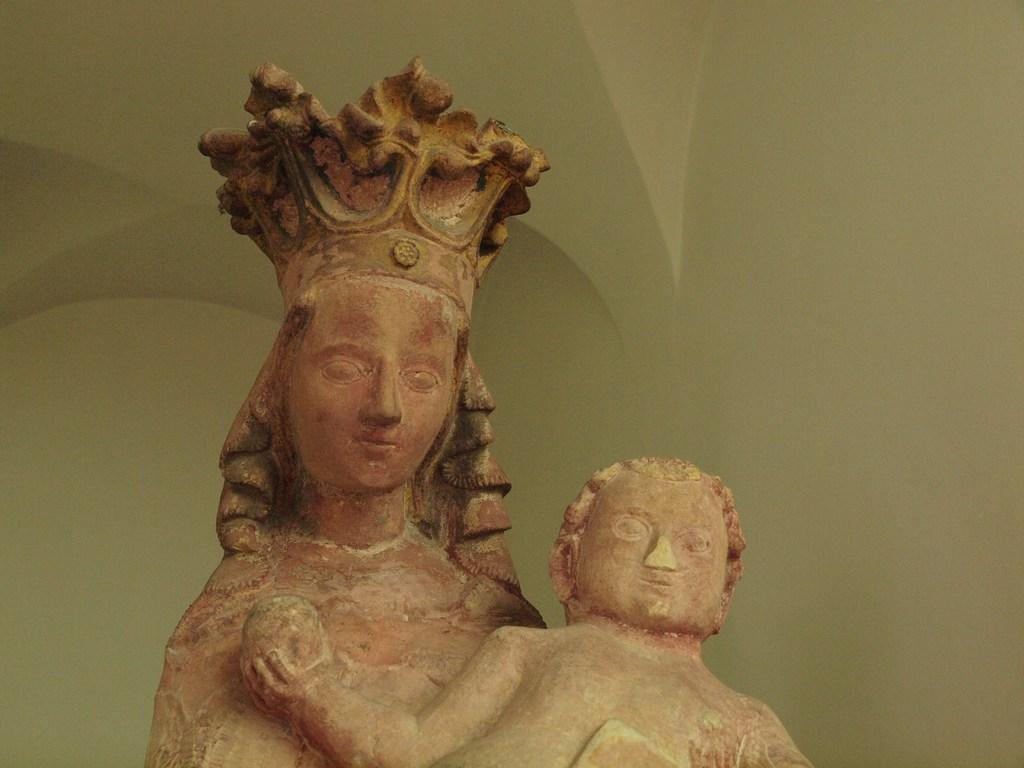What can be seen at the front of the image? There are statues in the front of the image. What is visible in the background of the image? There is a wall in the background of the image. Can you tell me how many monkeys are sitting on the statues in the image? There are no monkeys present in the image; it features statues without any animals. What type of milk is being poured on the wall in the background? There is no milk present in the image; it only shows a wall in the background. 